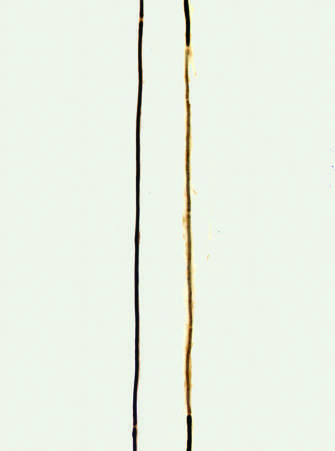s endometrioid type, grade 3, flanked by nodes of ranvier?
Answer the question using a single word or phrase. No 